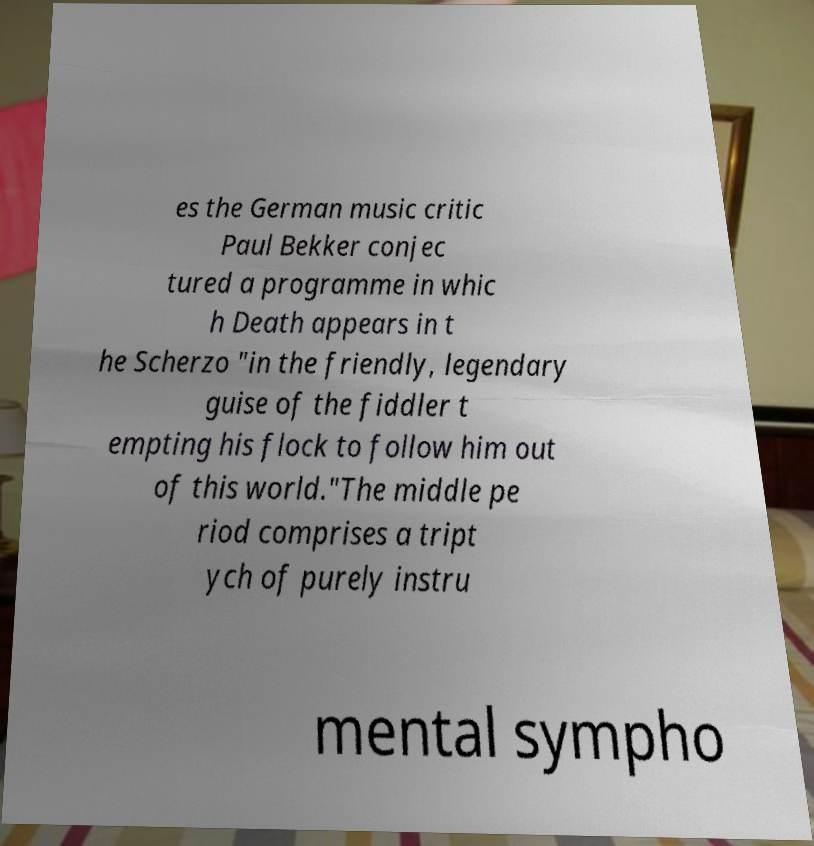Can you accurately transcribe the text from the provided image for me? es the German music critic Paul Bekker conjec tured a programme in whic h Death appears in t he Scherzo "in the friendly, legendary guise of the fiddler t empting his flock to follow him out of this world."The middle pe riod comprises a tript ych of purely instru mental sympho 